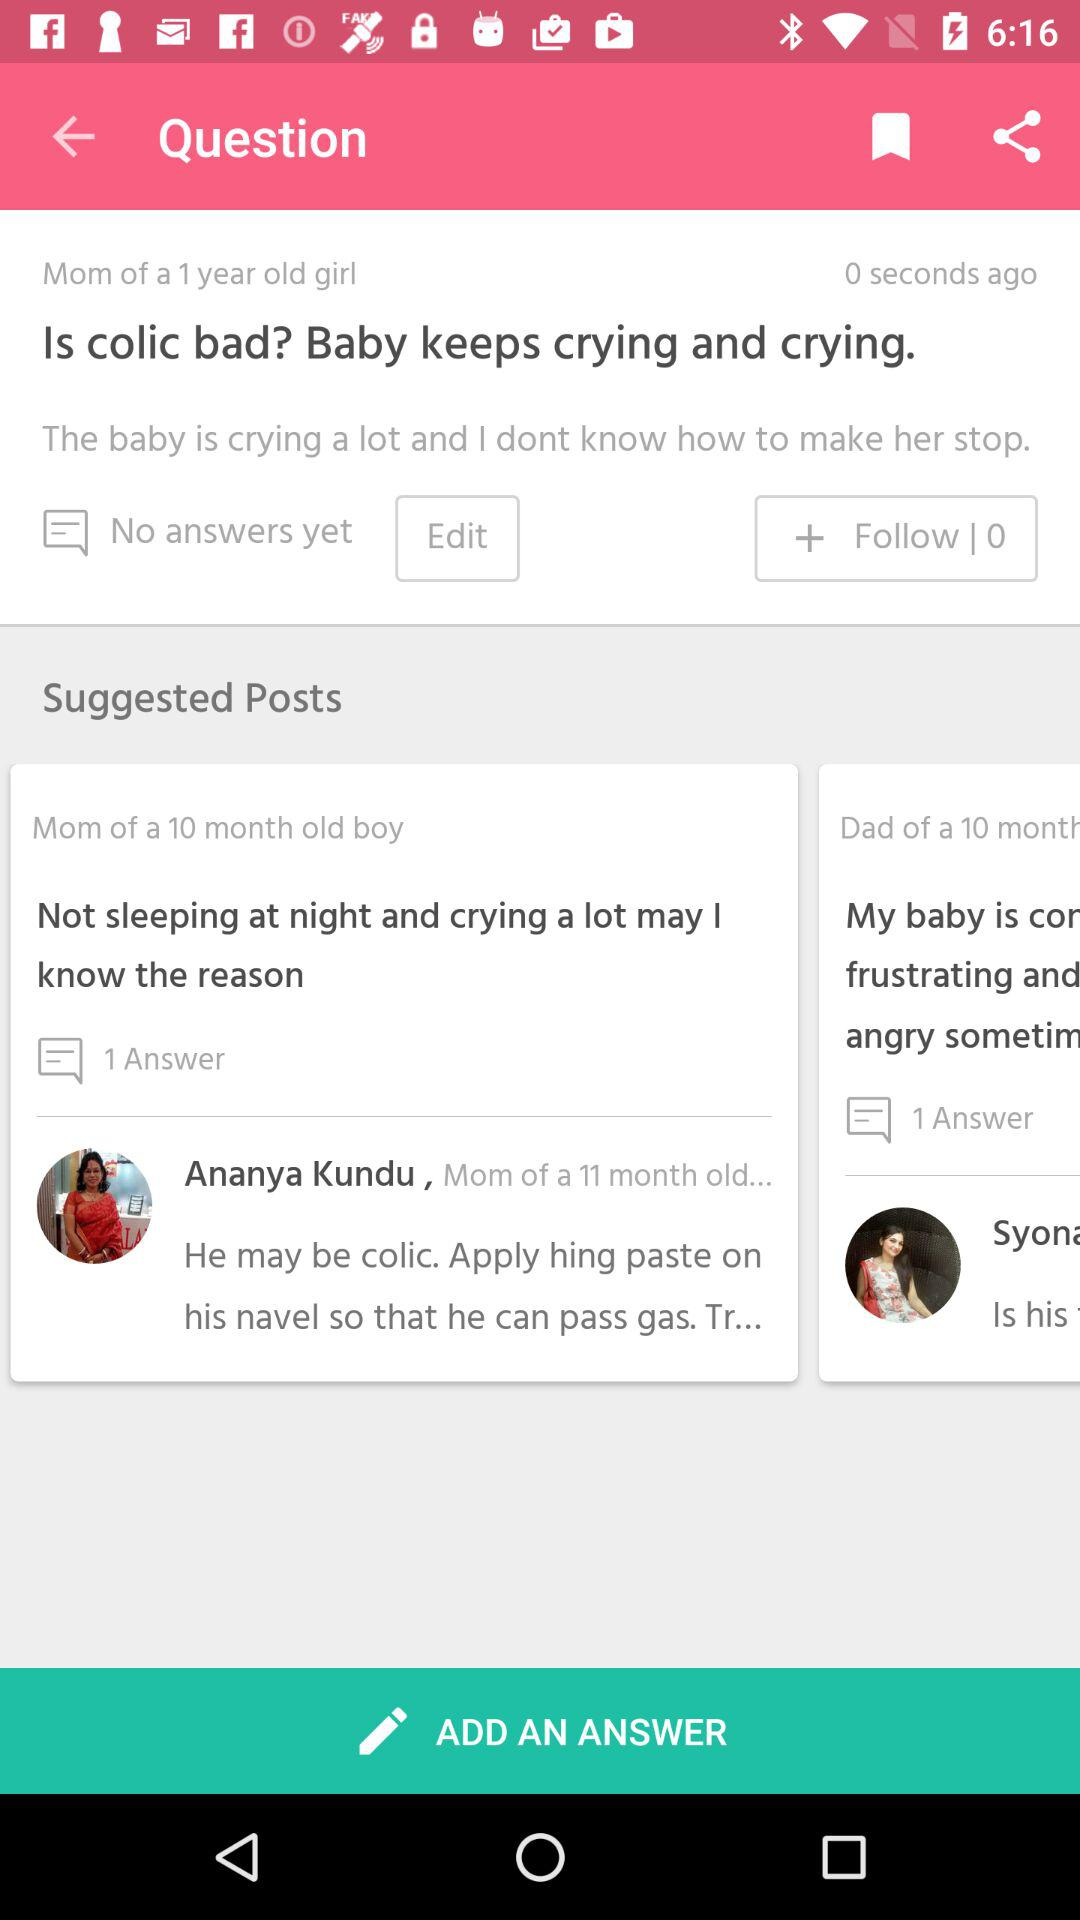What's the age of the girl? The girl is 1 year old. 